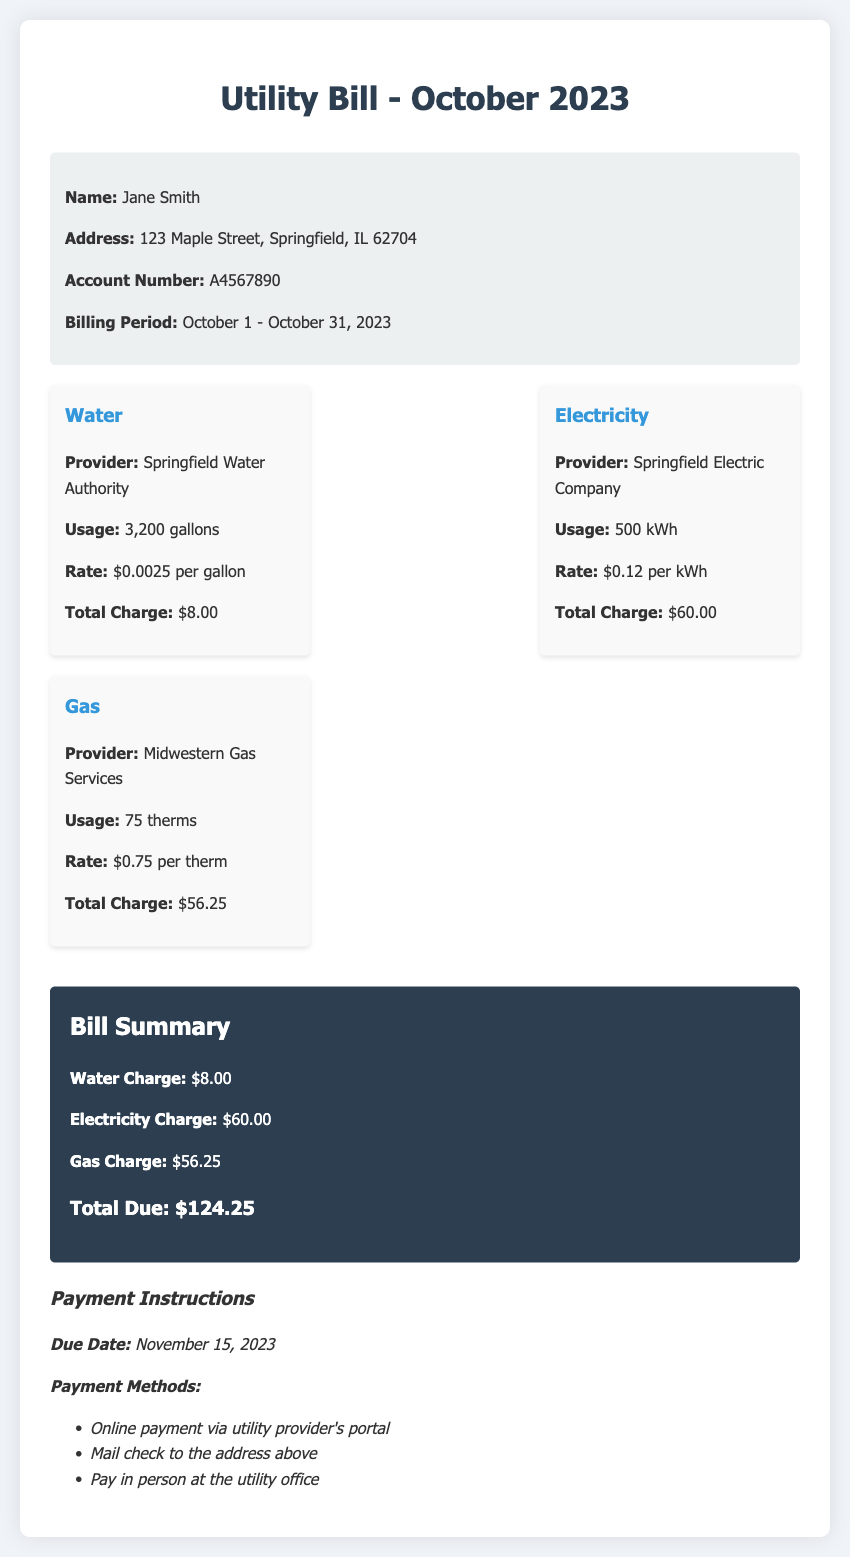What is the name of the account holder? The name of the account holder is stated in the customer info section of the document.
Answer: Jane Smith What is the total charge for water? The total charge for water is provided in the charges section of the document.
Answer: $8.00 How many gallons of water were used? The water usage is specified in the charges section of the document.
Answer: 3,200 gallons What is the total due amount? The total due amount is summarized at the end of the document.
Answer: $124.25 Which company provides the electricity? The electricity provider is listed under the electricity charge section.
Answer: Springfield Electric Company What is the billing period for this utility bill? The billing period is highlighted in the customer info section of the document.
Answer: October 1 - October 31, 2023 What is the rate per kWh for electricity? The electricity rate is indicated in the electricity charge section of the document.
Answer: $0.12 per kWh What payment method allows sending a check? Payment methods are listed at the end of the document, and one of them mentions sending a check.
Answer: Mail check How many therms of gas were used? The gas usage is mentioned in the charges section of the document.
Answer: 75 therms 